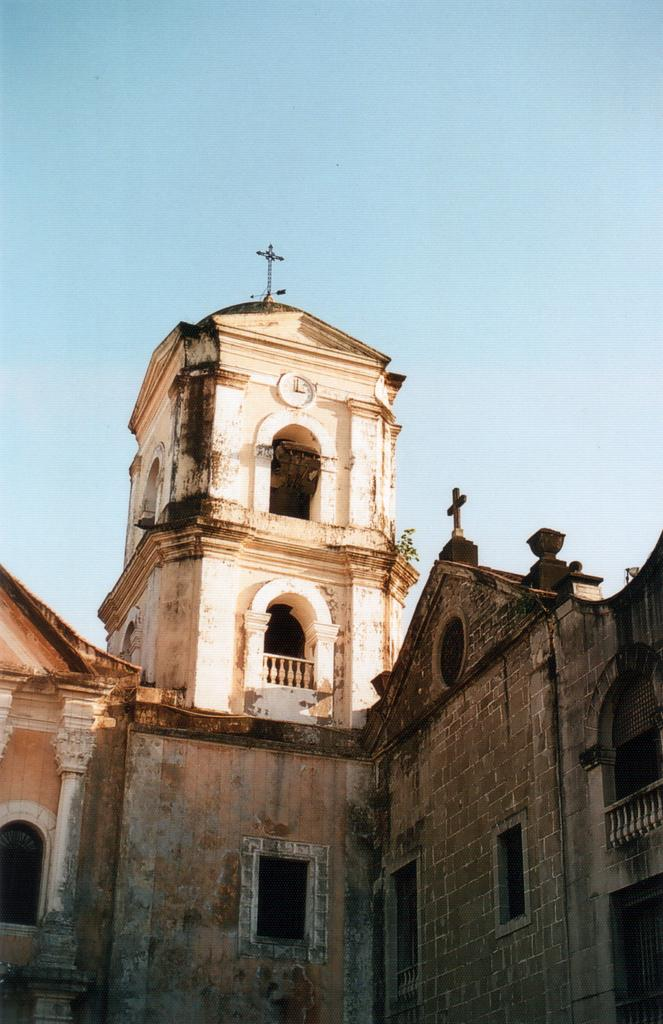What type of building is featured in the image? The image contains an outside view of a church building. Can you tell me how many times your aunt visited the church shop in the image? There is no mention of an aunt or a shop in the image; it features an outside view of a church building. How many breaths of fresh air can be taken while standing in front of the church in the image? The number of breaths cannot be determined from the image, as it only provides a visual representation of the church building. 